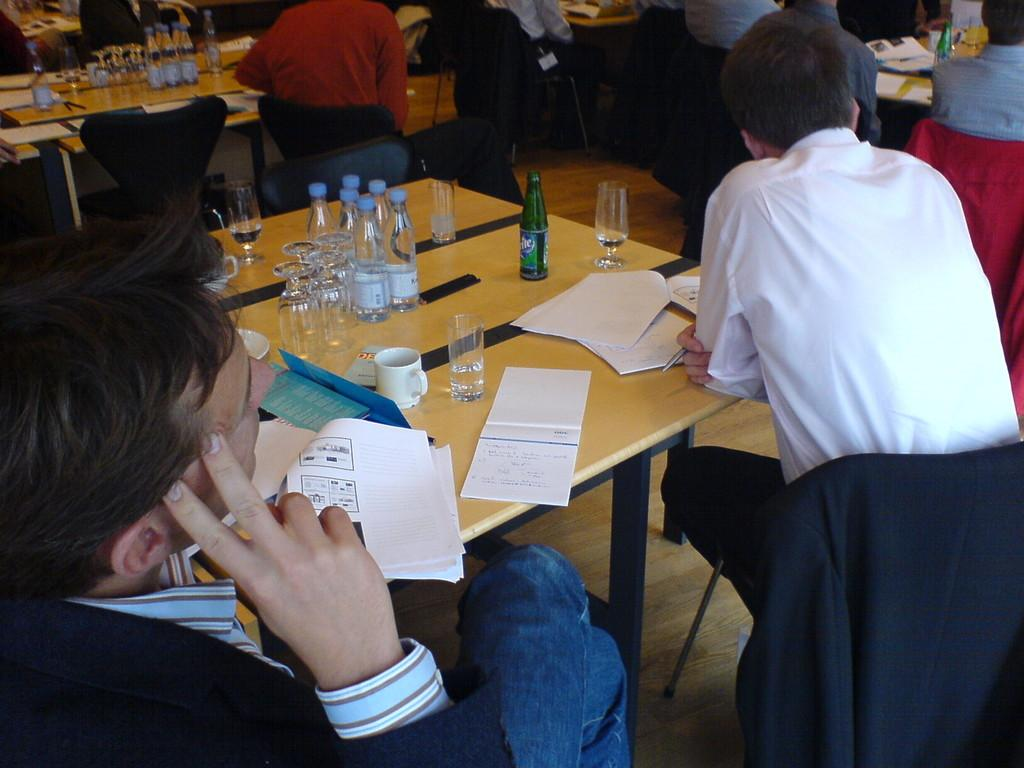What is the position of the person in the image? There is a person sitting on the left side of the image. What is in front of the person? There is a table in front of the person. What can be seen on the table? The table has papers, water bottles, and glasses on it. Who else is present in the image? There are a group of people in front of the person. How many dogs are comfortably sitting on the table in the image? There are no dogs present in the image, and the table is occupied by papers, water bottles, and glasses. 